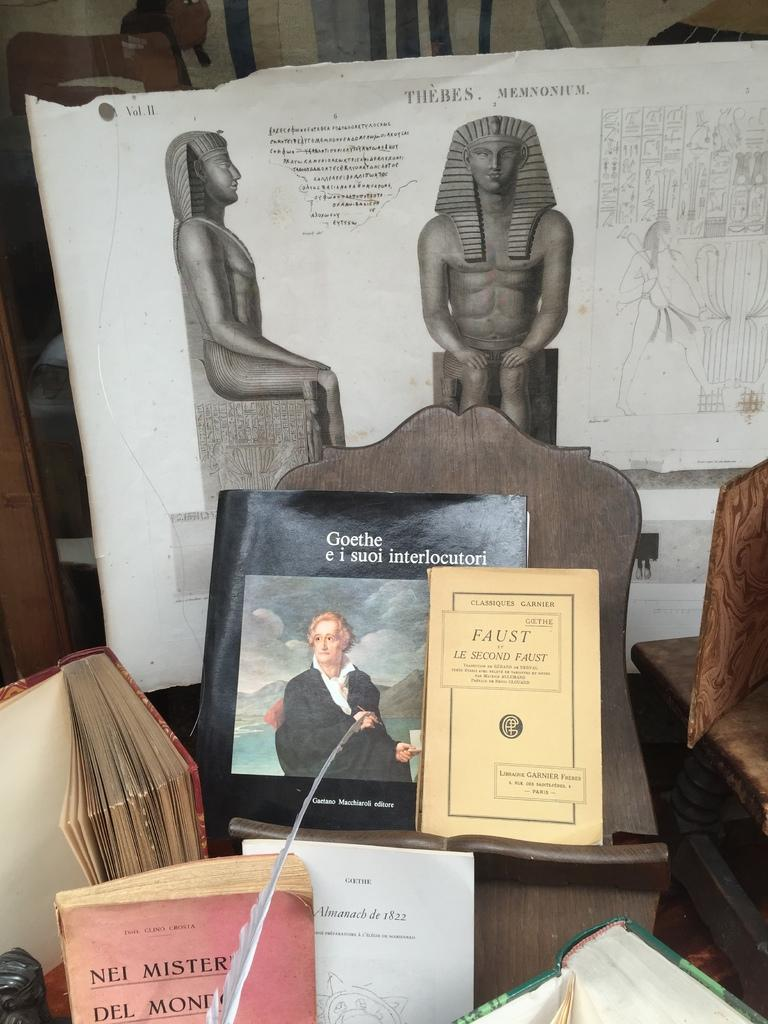<image>
Summarize the visual content of the image. display of several books including faust, nei mister, and goethe e i suoi interlocutori 